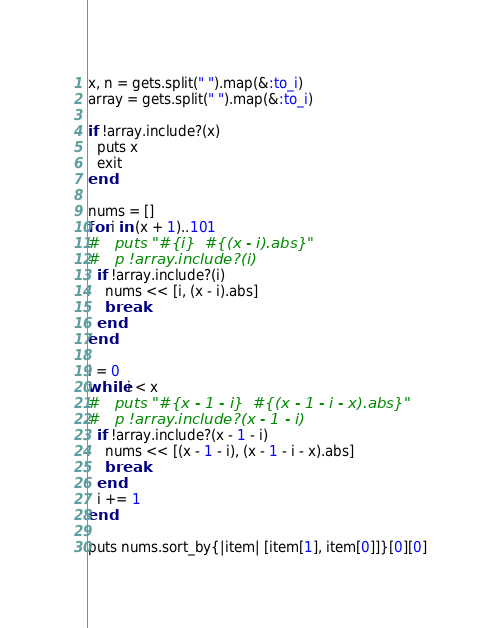Convert code to text. <code><loc_0><loc_0><loc_500><loc_500><_Ruby_>x, n = gets.split(" ").map(&:to_i)
array = gets.split(" ").map(&:to_i)

if !array.include?(x)
  puts x
  exit
end

nums = []
for i in (x + 1)..101
#   puts "#{i}  #{(x - i).abs}"
#   p !array.include?(i)
  if !array.include?(i)
    nums << [i, (x - i).abs]
    break
  end
end

i = 0
while i < x
#   puts "#{x - 1 - i}  #{(x - 1 - i - x).abs}"
#   p !array.include?(x - 1 - i)
  if !array.include?(x - 1 - i)
    nums << [(x - 1 - i), (x - 1 - i - x).abs]
    break
  end
  i += 1
end

puts nums.sort_by{|item| [item[1], item[0]]}[0][0]</code> 